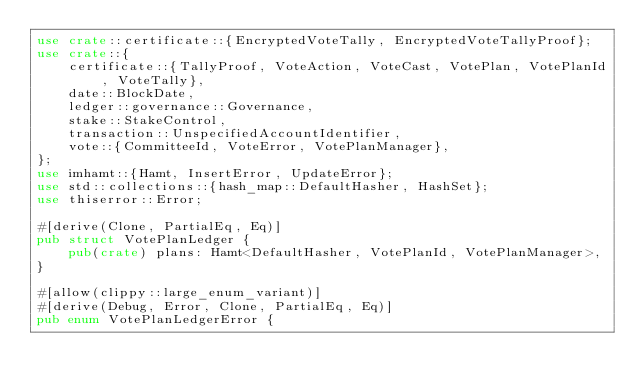<code> <loc_0><loc_0><loc_500><loc_500><_Rust_>use crate::certificate::{EncryptedVoteTally, EncryptedVoteTallyProof};
use crate::{
    certificate::{TallyProof, VoteAction, VoteCast, VotePlan, VotePlanId, VoteTally},
    date::BlockDate,
    ledger::governance::Governance,
    stake::StakeControl,
    transaction::UnspecifiedAccountIdentifier,
    vote::{CommitteeId, VoteError, VotePlanManager},
};
use imhamt::{Hamt, InsertError, UpdateError};
use std::collections::{hash_map::DefaultHasher, HashSet};
use thiserror::Error;

#[derive(Clone, PartialEq, Eq)]
pub struct VotePlanLedger {
    pub(crate) plans: Hamt<DefaultHasher, VotePlanId, VotePlanManager>,
}

#[allow(clippy::large_enum_variant)]
#[derive(Debug, Error, Clone, PartialEq, Eq)]
pub enum VotePlanLedgerError {</code> 